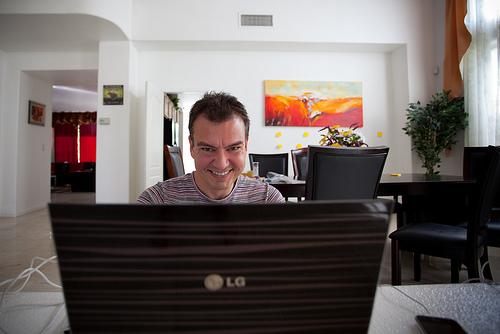Tell me the general sentiment expressed in this image. The man is happily using his laptop, reflecting a positive sentiment in the image. Describe the location of the green plant in the image. The green plant is next to the window and the curtain, located in the corner of the room. How many yellow stickers are on the wall and where are they located? There are five yellow stickers on the wall, three of them are located near the orange picture and two are nearby. What type of artwork is displayed in the image? There are several pictures hanging on the wall, and a large painting as well. What is the man wearing in the image? The man is wearing a striped shirt and has brown hair. Provide an overall description of the setup in the room. There is a man using a laptop on a grey desk with a phone and white cables. In the corner of the room, there is a small plant, and in the other room, there are dining table and chairs. Which electronic devices are present on the desk? A black and glossy LG laptop and a phone are present on the desk. Are there any objects attached to the phone on the desk? Yes, there is a white cord attached to the phone. What type of furniture is present in the other room? There is a dining room table, chairs, and black empty chairs in the other room. Explain the complex reasoning depicted in the image. The man in a striped shirt is using a laptop, which signifies productivity and technological engagement, while simultaneously, the dining room setup in the other room represents a more relaxing and social environment. This juxtaposition suggests a balance between work and leisure time. 